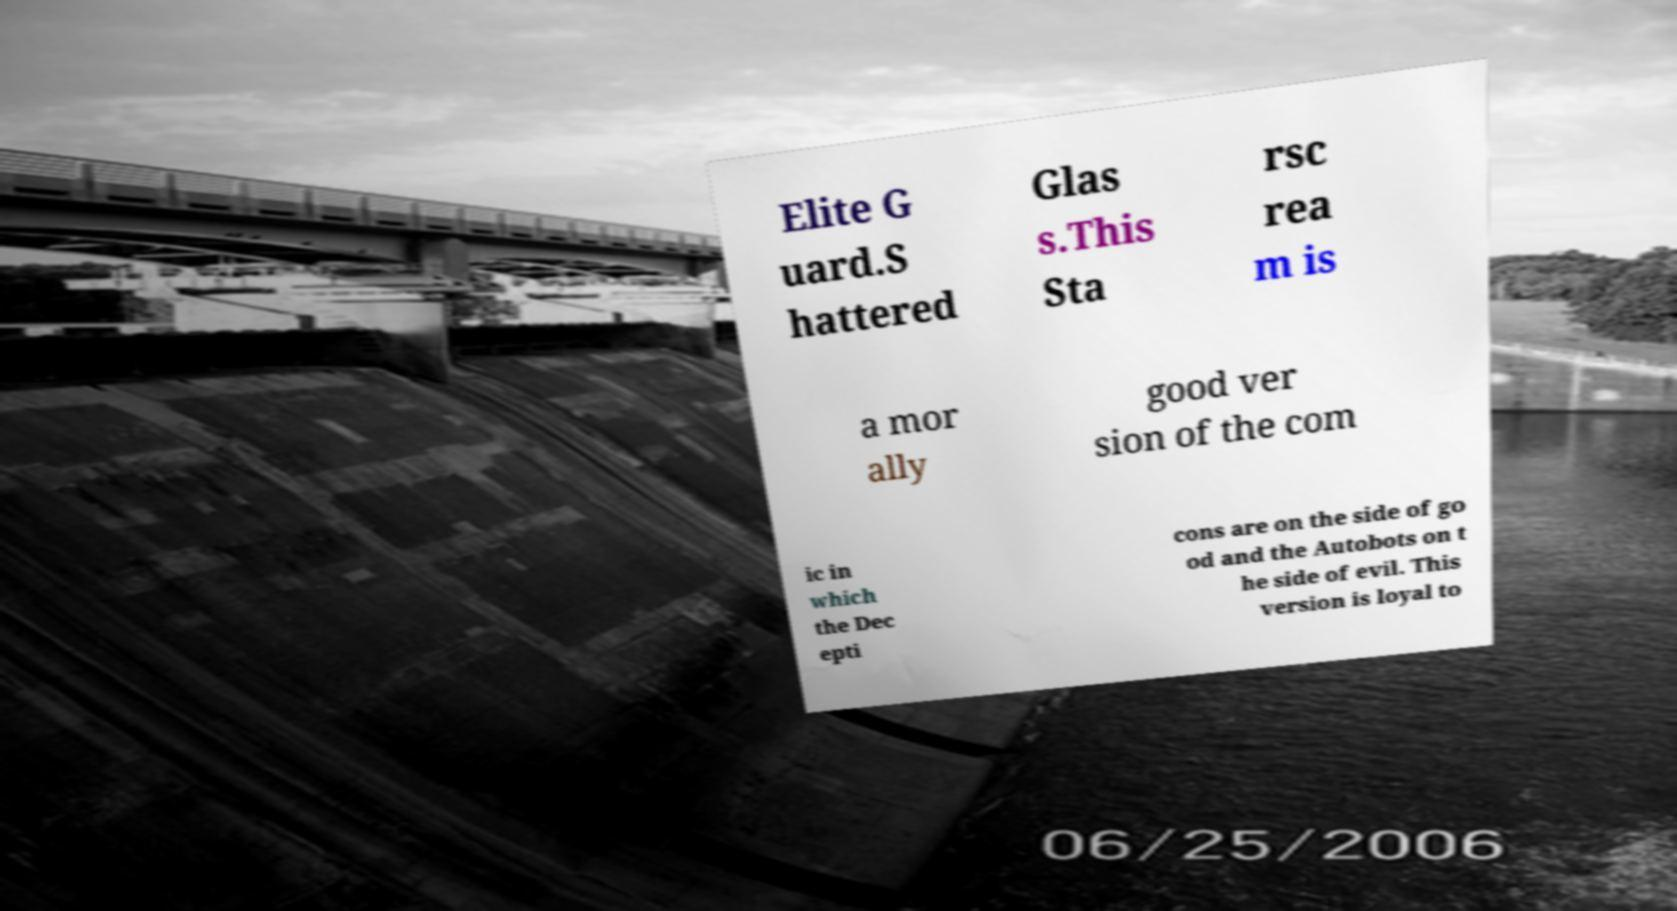Can you accurately transcribe the text from the provided image for me? Elite G uard.S hattered Glas s.This Sta rsc rea m is a mor ally good ver sion of the com ic in which the Dec epti cons are on the side of go od and the Autobots on t he side of evil. This version is loyal to 